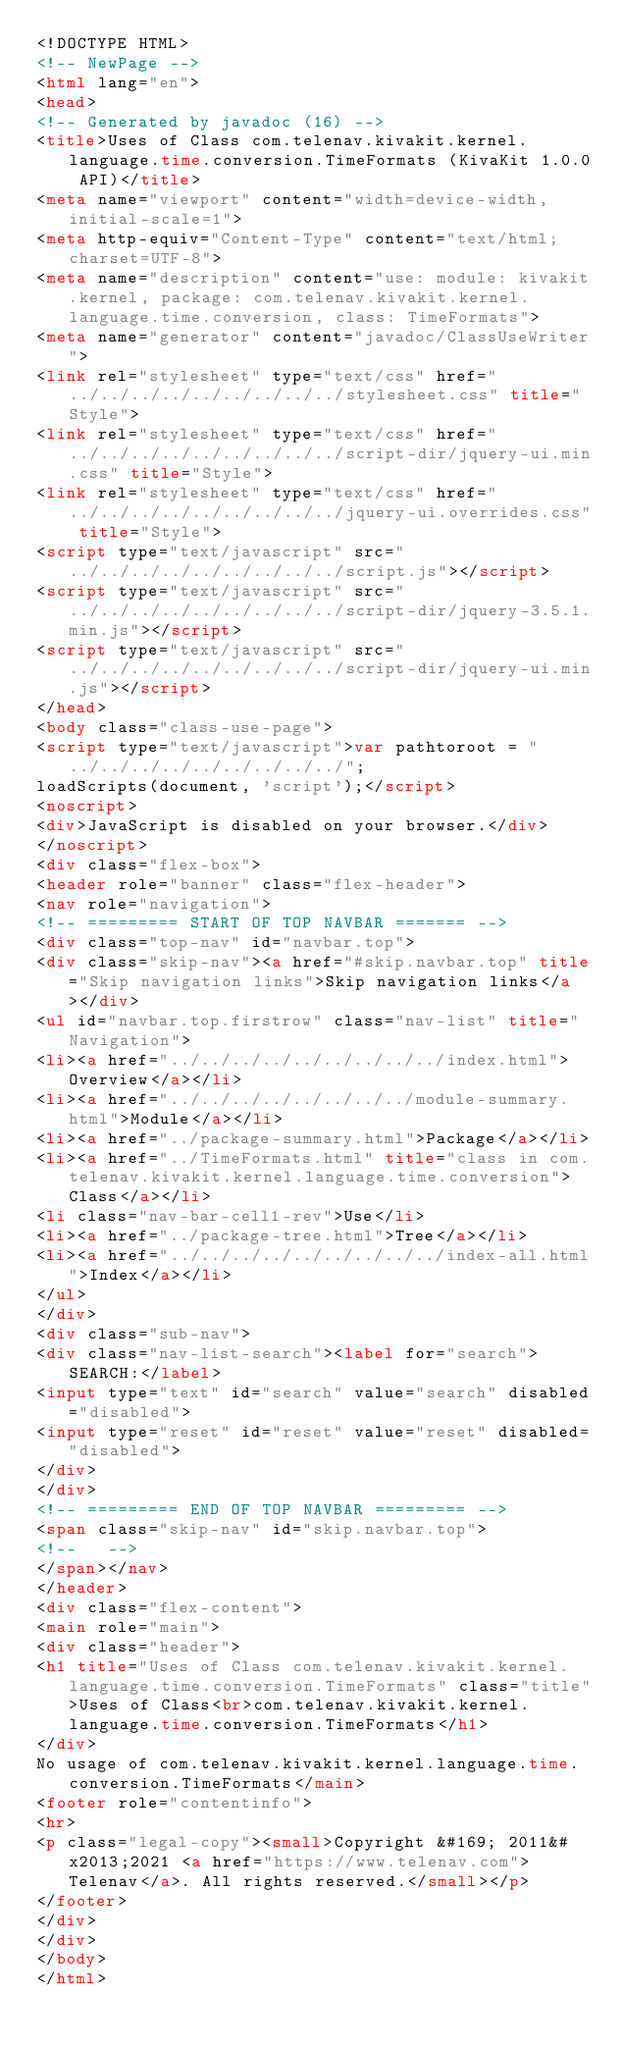<code> <loc_0><loc_0><loc_500><loc_500><_HTML_><!DOCTYPE HTML>
<!-- NewPage -->
<html lang="en">
<head>
<!-- Generated by javadoc (16) -->
<title>Uses of Class com.telenav.kivakit.kernel.language.time.conversion.TimeFormats (KivaKit 1.0.0 API)</title>
<meta name="viewport" content="width=device-width, initial-scale=1">
<meta http-equiv="Content-Type" content="text/html; charset=UTF-8">
<meta name="description" content="use: module: kivakit.kernel, package: com.telenav.kivakit.kernel.language.time.conversion, class: TimeFormats">
<meta name="generator" content="javadoc/ClassUseWriter">
<link rel="stylesheet" type="text/css" href="../../../../../../../../../stylesheet.css" title="Style">
<link rel="stylesheet" type="text/css" href="../../../../../../../../../script-dir/jquery-ui.min.css" title="Style">
<link rel="stylesheet" type="text/css" href="../../../../../../../../../jquery-ui.overrides.css" title="Style">
<script type="text/javascript" src="../../../../../../../../../script.js"></script>
<script type="text/javascript" src="../../../../../../../../../script-dir/jquery-3.5.1.min.js"></script>
<script type="text/javascript" src="../../../../../../../../../script-dir/jquery-ui.min.js"></script>
</head>
<body class="class-use-page">
<script type="text/javascript">var pathtoroot = "../../../../../../../../../";
loadScripts(document, 'script');</script>
<noscript>
<div>JavaScript is disabled on your browser.</div>
</noscript>
<div class="flex-box">
<header role="banner" class="flex-header">
<nav role="navigation">
<!-- ========= START OF TOP NAVBAR ======= -->
<div class="top-nav" id="navbar.top">
<div class="skip-nav"><a href="#skip.navbar.top" title="Skip navigation links">Skip navigation links</a></div>
<ul id="navbar.top.firstrow" class="nav-list" title="Navigation">
<li><a href="../../../../../../../../../index.html">Overview</a></li>
<li><a href="../../../../../../../../module-summary.html">Module</a></li>
<li><a href="../package-summary.html">Package</a></li>
<li><a href="../TimeFormats.html" title="class in com.telenav.kivakit.kernel.language.time.conversion">Class</a></li>
<li class="nav-bar-cell1-rev">Use</li>
<li><a href="../package-tree.html">Tree</a></li>
<li><a href="../../../../../../../../../index-all.html">Index</a></li>
</ul>
</div>
<div class="sub-nav">
<div class="nav-list-search"><label for="search">SEARCH:</label>
<input type="text" id="search" value="search" disabled="disabled">
<input type="reset" id="reset" value="reset" disabled="disabled">
</div>
</div>
<!-- ========= END OF TOP NAVBAR ========= -->
<span class="skip-nav" id="skip.navbar.top">
<!--   -->
</span></nav>
</header>
<div class="flex-content">
<main role="main">
<div class="header">
<h1 title="Uses of Class com.telenav.kivakit.kernel.language.time.conversion.TimeFormats" class="title">Uses of Class<br>com.telenav.kivakit.kernel.language.time.conversion.TimeFormats</h1>
</div>
No usage of com.telenav.kivakit.kernel.language.time.conversion.TimeFormats</main>
<footer role="contentinfo">
<hr>
<p class="legal-copy"><small>Copyright &#169; 2011&#x2013;2021 <a href="https://www.telenav.com">Telenav</a>. All rights reserved.</small></p>
</footer>
</div>
</div>
</body>
</html>
</code> 